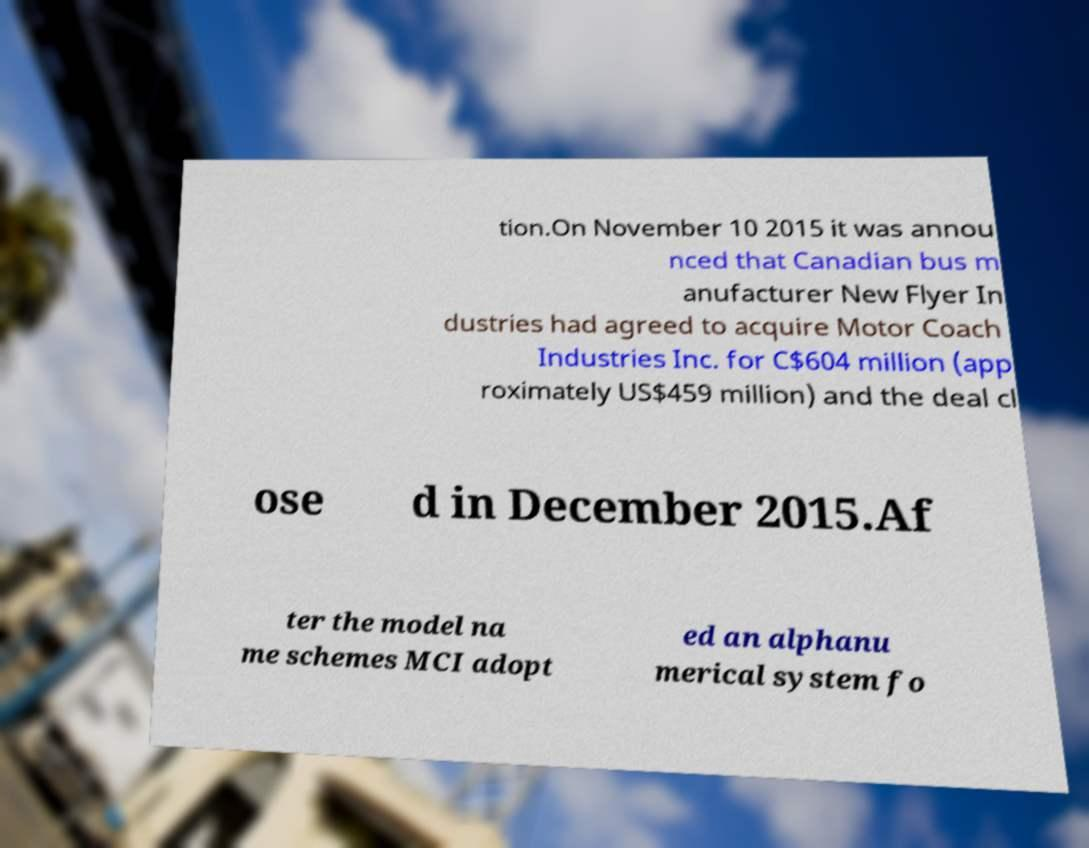Please identify and transcribe the text found in this image. tion.On November 10 2015 it was annou nced that Canadian bus m anufacturer New Flyer In dustries had agreed to acquire Motor Coach Industries Inc. for C$604 million (app roximately US$459 million) and the deal cl ose d in December 2015.Af ter the model na me schemes MCI adopt ed an alphanu merical system fo 